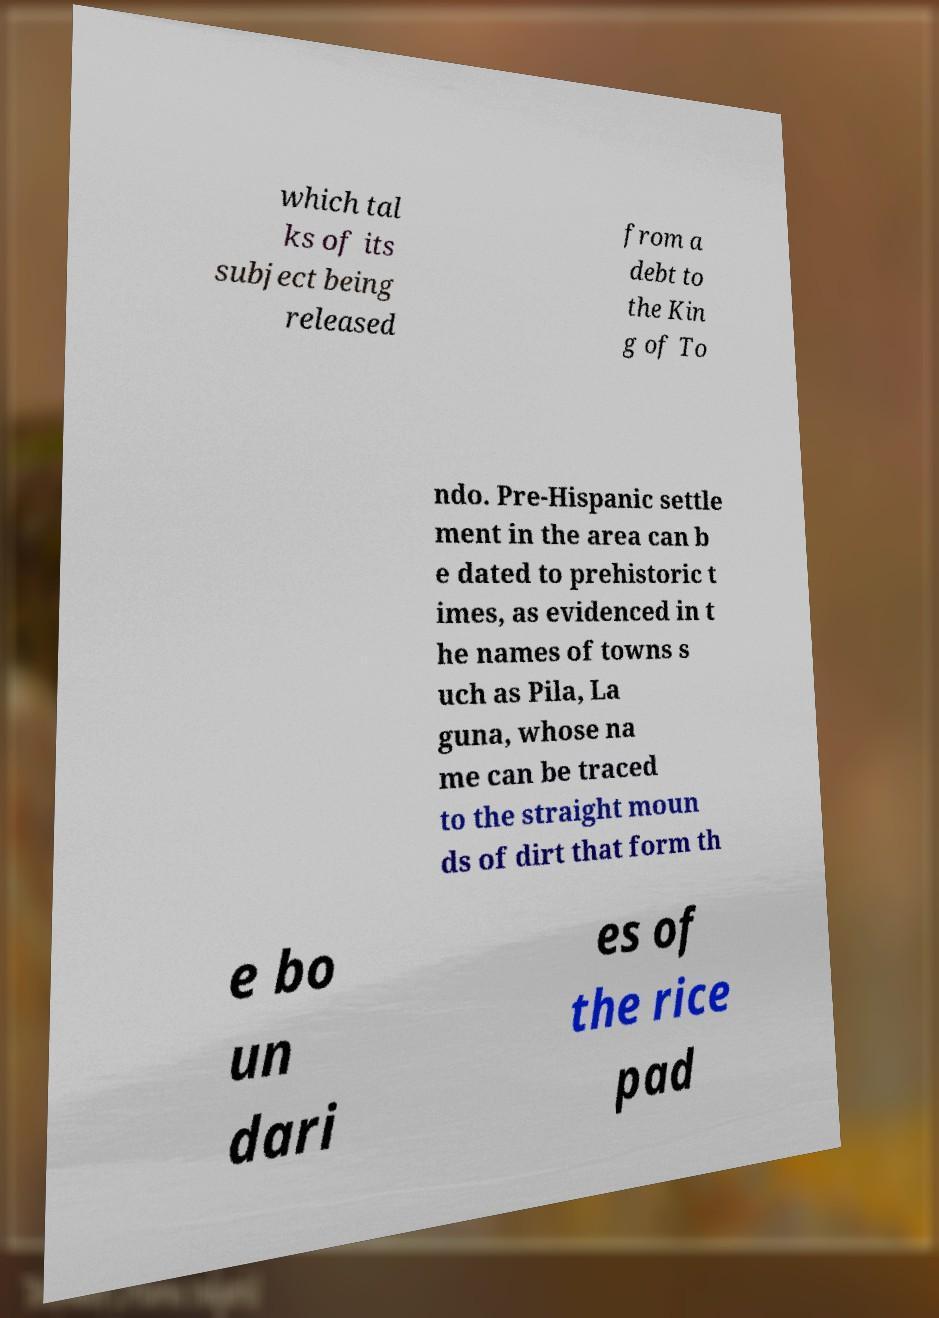What messages or text are displayed in this image? I need them in a readable, typed format. which tal ks of its subject being released from a debt to the Kin g of To ndo. Pre-Hispanic settle ment in the area can b e dated to prehistoric t imes, as evidenced in t he names of towns s uch as Pila, La guna, whose na me can be traced to the straight moun ds of dirt that form th e bo un dari es of the rice pad 